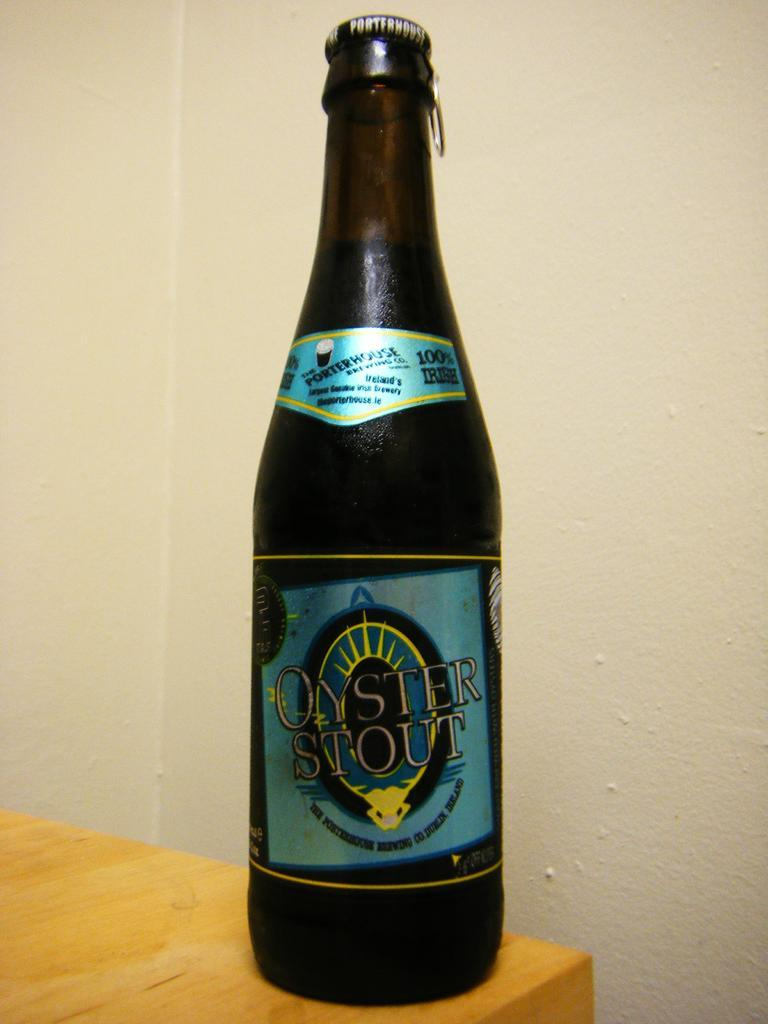<image>
Relay a brief, clear account of the picture shown. A bottle of Oyster Stout on the corner of a table. 